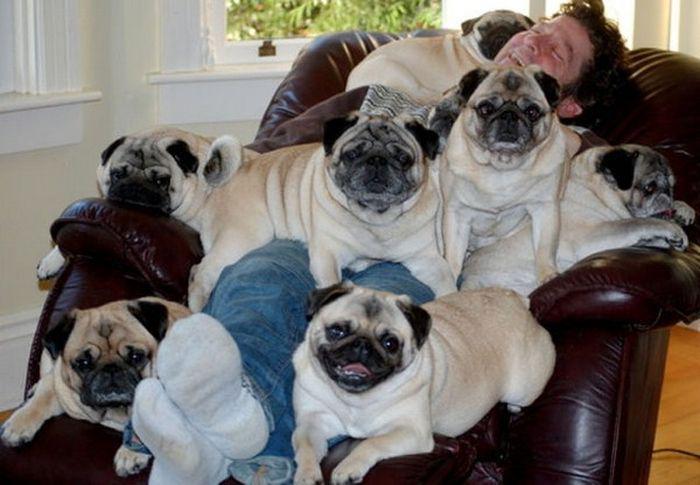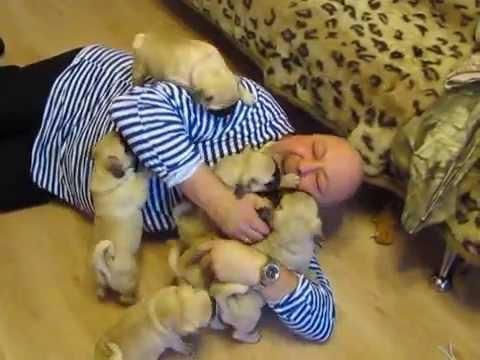The first image is the image on the left, the second image is the image on the right. Analyze the images presented: Is the assertion "A human is playing with puppies on the floor" valid? Answer yes or no. Yes. The first image is the image on the left, the second image is the image on the right. Examine the images to the left and right. Is the description "A man in a blue and white striped shirt is nuzzling puppies." accurate? Answer yes or no. Yes. 